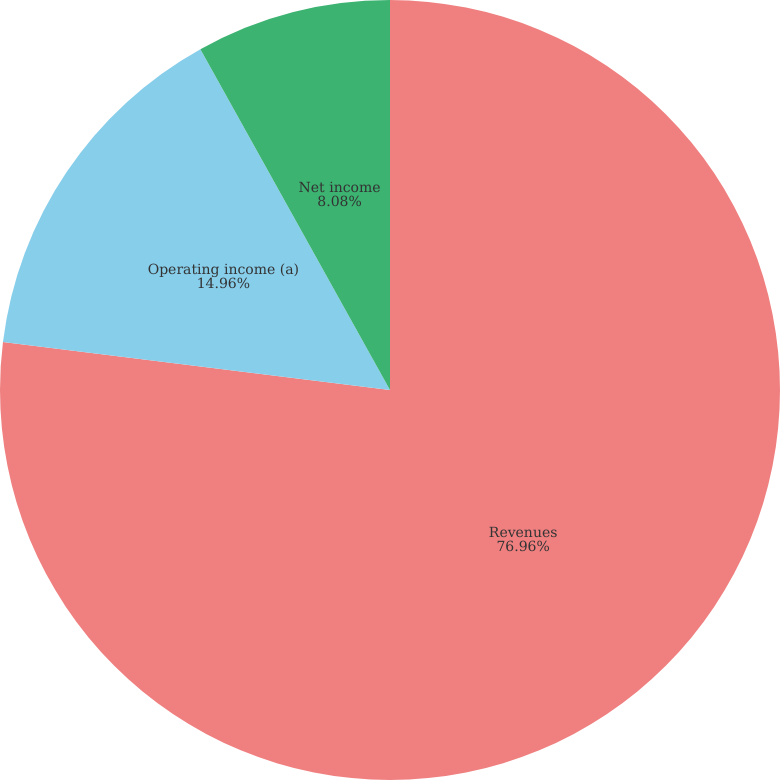<chart> <loc_0><loc_0><loc_500><loc_500><pie_chart><fcel>Revenues<fcel>Operating income (a)<fcel>Net income<nl><fcel>76.96%<fcel>14.96%<fcel>8.08%<nl></chart> 